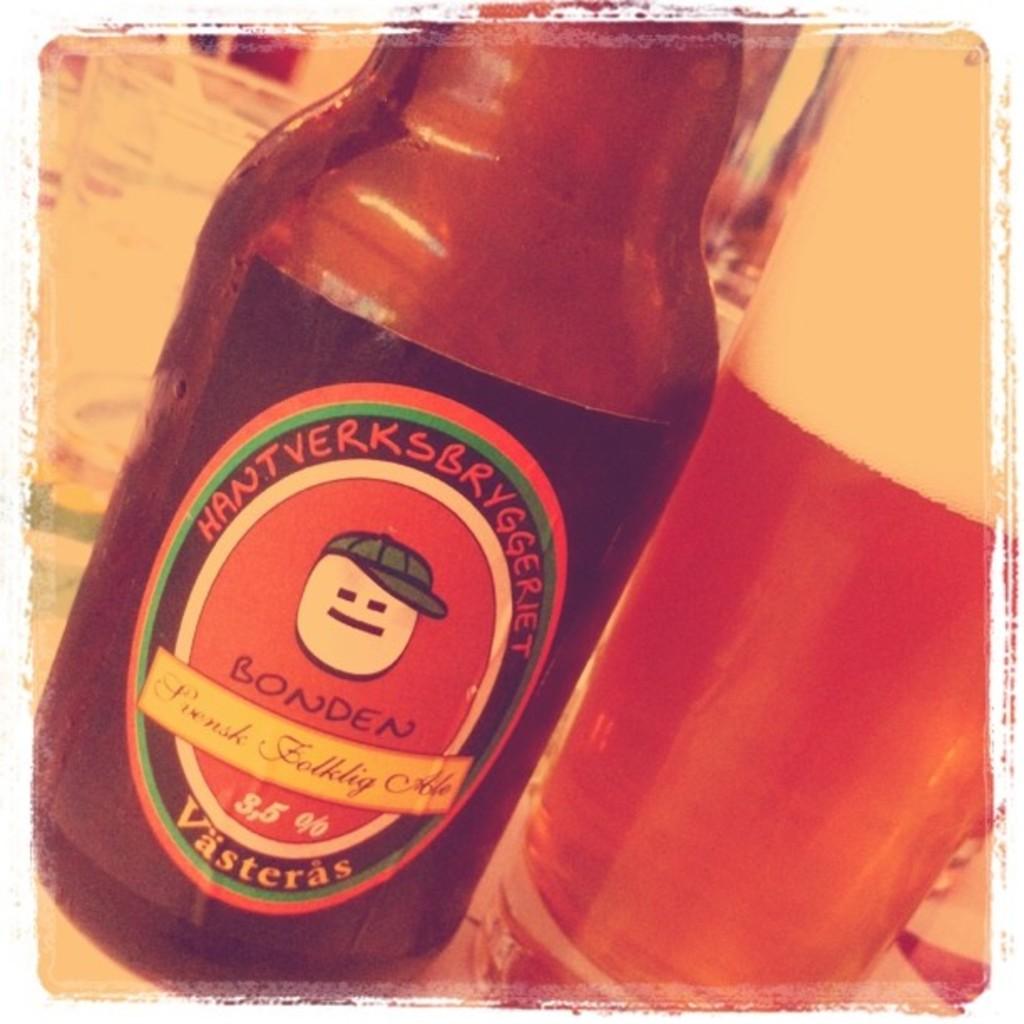What is the brand of beer?
Ensure brevity in your answer.  Bonden. 